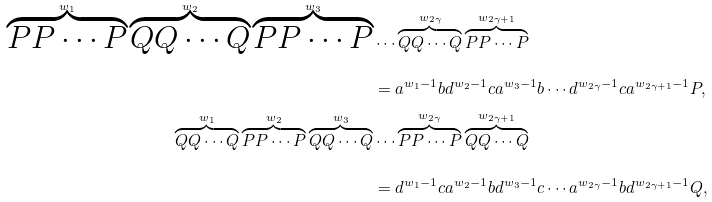Convert formula to latex. <formula><loc_0><loc_0><loc_500><loc_500>\overbrace { P P \cdots P } ^ { w _ { 1 } } \overbrace { Q Q \cdots Q } ^ { w _ { 2 } } \overbrace { P P \cdots P } ^ { w _ { 3 } } & \cdots \overbrace { Q Q \cdots Q } ^ { w _ { 2 \gamma } } \overbrace { P P \cdots P } ^ { w _ { 2 \gamma + 1 } } \\ & = a ^ { w _ { 1 } - 1 } b d ^ { w _ { 2 } - 1 } c a ^ { w _ { 3 } - 1 } b \cdots d ^ { w _ { 2 \gamma } - 1 } c a ^ { w _ { 2 \gamma + 1 } - 1 } P , \\ \overbrace { Q Q \cdots Q } ^ { w _ { 1 } } \overbrace { P P \cdots P } ^ { w _ { 2 } } \overbrace { Q Q \cdots Q } ^ { w _ { 3 } } & \cdots \overbrace { P P \cdots P } ^ { w _ { 2 \gamma } } \overbrace { Q Q \cdots Q } ^ { w _ { 2 \gamma + 1 } } \\ & = d ^ { w _ { 1 } - 1 } c a ^ { w _ { 2 } - 1 } b d ^ { w _ { 3 } - 1 } c \cdots a ^ { w _ { 2 \gamma } - 1 } b d ^ { w _ { 2 \gamma + 1 } - 1 } Q ,</formula> 